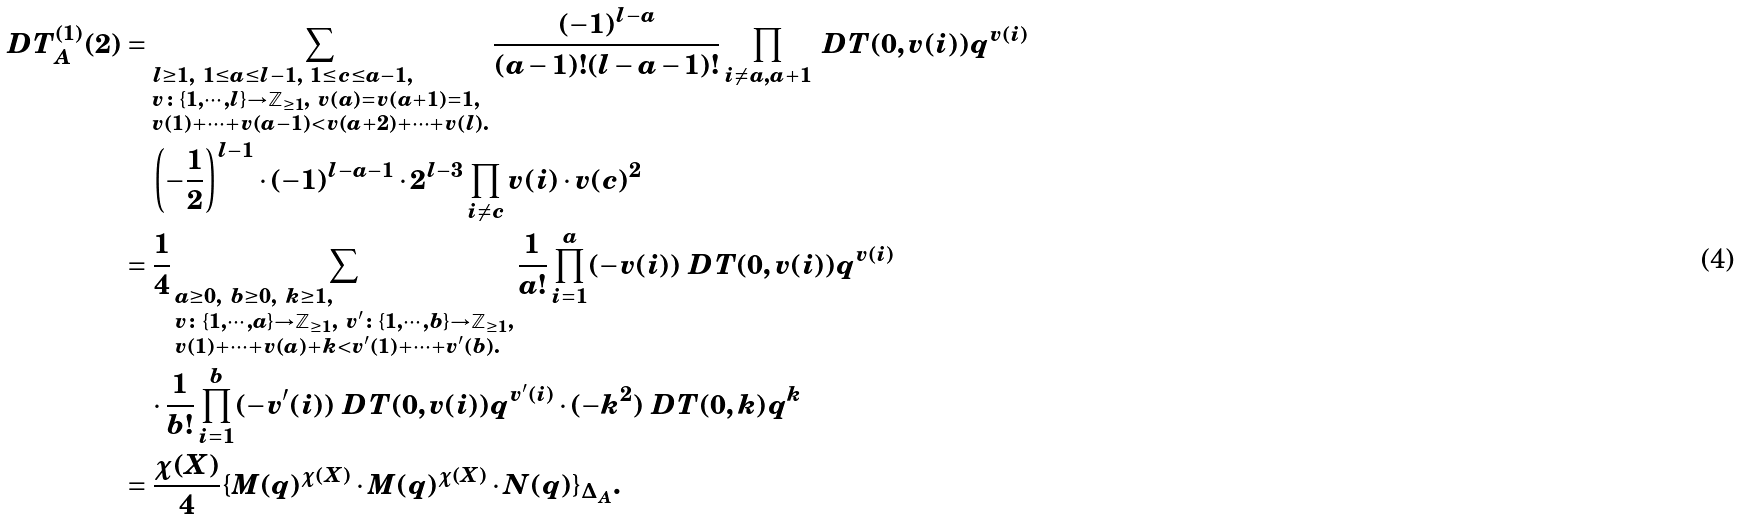Convert formula to latex. <formula><loc_0><loc_0><loc_500><loc_500>\ D T _ { A } ^ { ( 1 ) } ( 2 ) & = \sum _ { \begin{subarray} { c } l \geq 1 , \ 1 \leq a \leq l - 1 , \ 1 \leq c \leq a - 1 , \\ v \colon \{ 1 , \cdots , l \} \to \mathbb { Z } _ { \geq 1 } , \ v ( a ) = v ( a + 1 ) = 1 , \\ v ( 1 ) + \cdots + v ( a - 1 ) < v ( a + 2 ) + \cdots + v ( l ) . \end{subarray} } \frac { ( - 1 ) ^ { l - a } } { ( a - 1 ) ! ( l - a - 1 ) ! } \prod _ { i \neq a , a + 1 } \ D T ( 0 , v ( i ) ) q ^ { v ( i ) } \\ & \quad \left ( - \frac { 1 } { 2 } \right ) ^ { l - 1 } \cdot ( - 1 ) ^ { l - a - 1 } \cdot 2 ^ { l - 3 } \prod _ { i \neq c } v ( i ) \cdot v ( c ) ^ { 2 } \\ & = \frac { 1 } { 4 } \sum _ { \begin{subarray} { c } a \geq 0 , \ b \geq 0 , \ k \geq 1 , \\ v \colon \{ 1 , \cdots , a \} \to \mathbb { Z } _ { \geq 1 } , \ v ^ { \prime } \colon \{ 1 , \cdots , b \} \to \mathbb { Z } _ { \geq 1 } , \\ v ( 1 ) + \cdots + v ( a ) + k < v ^ { \prime } ( 1 ) + \cdots + v ^ { \prime } ( b ) . \end{subarray} } \frac { 1 } { a ! } \prod _ { i = 1 } ^ { a } ( - v ( i ) ) \ D T ( 0 , v ( i ) ) q ^ { v ( i ) } \\ & \quad \cdot \frac { 1 } { b ! } \prod _ { i = 1 } ^ { b } ( - v ^ { \prime } ( i ) ) \ D T ( 0 , v ( i ) ) q ^ { v ^ { \prime } ( i ) } \cdot ( - k ^ { 2 } ) \ D T ( 0 , k ) q ^ { k } \\ & = \frac { \chi ( X ) } { 4 } \{ M ( q ) ^ { \chi ( X ) } \cdot M ( q ) ^ { \chi ( X ) } \cdot N ( q ) \} _ { \Delta _ { A } } .</formula> 